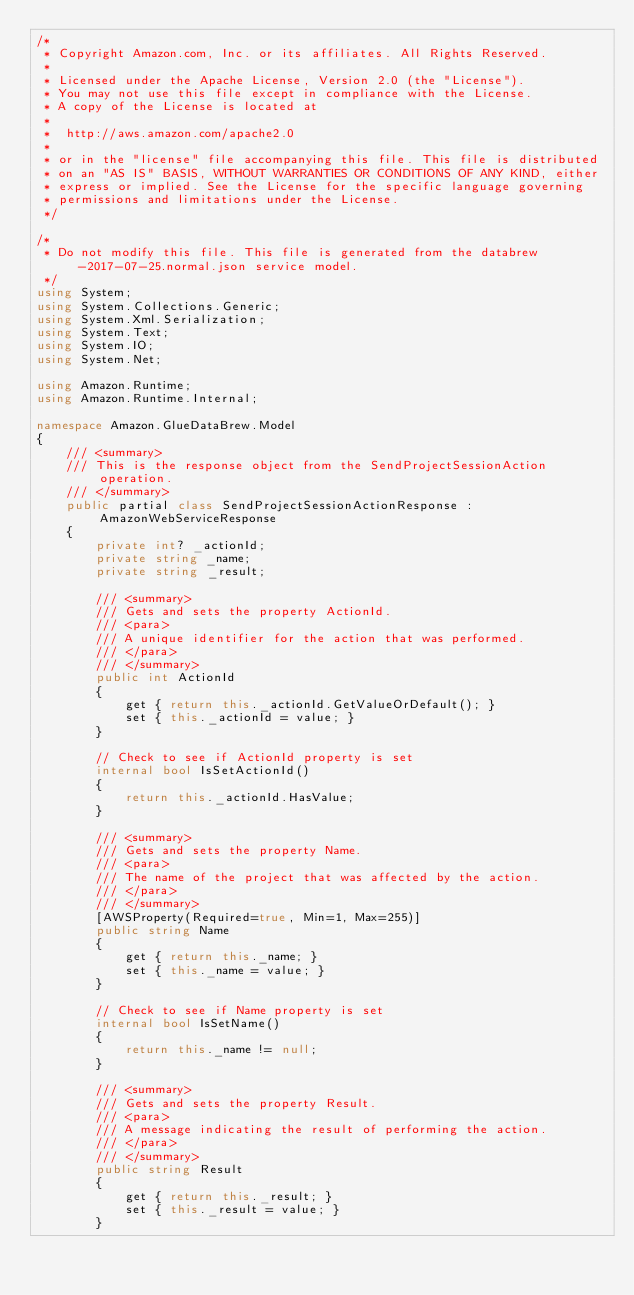Convert code to text. <code><loc_0><loc_0><loc_500><loc_500><_C#_>/*
 * Copyright Amazon.com, Inc. or its affiliates. All Rights Reserved.
 * 
 * Licensed under the Apache License, Version 2.0 (the "License").
 * You may not use this file except in compliance with the License.
 * A copy of the License is located at
 * 
 *  http://aws.amazon.com/apache2.0
 * 
 * or in the "license" file accompanying this file. This file is distributed
 * on an "AS IS" BASIS, WITHOUT WARRANTIES OR CONDITIONS OF ANY KIND, either
 * express or implied. See the License for the specific language governing
 * permissions and limitations under the License.
 */

/*
 * Do not modify this file. This file is generated from the databrew-2017-07-25.normal.json service model.
 */
using System;
using System.Collections.Generic;
using System.Xml.Serialization;
using System.Text;
using System.IO;
using System.Net;

using Amazon.Runtime;
using Amazon.Runtime.Internal;

namespace Amazon.GlueDataBrew.Model
{
    /// <summary>
    /// This is the response object from the SendProjectSessionAction operation.
    /// </summary>
    public partial class SendProjectSessionActionResponse : AmazonWebServiceResponse
    {
        private int? _actionId;
        private string _name;
        private string _result;

        /// <summary>
        /// Gets and sets the property ActionId. 
        /// <para>
        /// A unique identifier for the action that was performed.
        /// </para>
        /// </summary>
        public int ActionId
        {
            get { return this._actionId.GetValueOrDefault(); }
            set { this._actionId = value; }
        }

        // Check to see if ActionId property is set
        internal bool IsSetActionId()
        {
            return this._actionId.HasValue; 
        }

        /// <summary>
        /// Gets and sets the property Name. 
        /// <para>
        /// The name of the project that was affected by the action.
        /// </para>
        /// </summary>
        [AWSProperty(Required=true, Min=1, Max=255)]
        public string Name
        {
            get { return this._name; }
            set { this._name = value; }
        }

        // Check to see if Name property is set
        internal bool IsSetName()
        {
            return this._name != null;
        }

        /// <summary>
        /// Gets and sets the property Result. 
        /// <para>
        /// A message indicating the result of performing the action.
        /// </para>
        /// </summary>
        public string Result
        {
            get { return this._result; }
            set { this._result = value; }
        }
</code> 